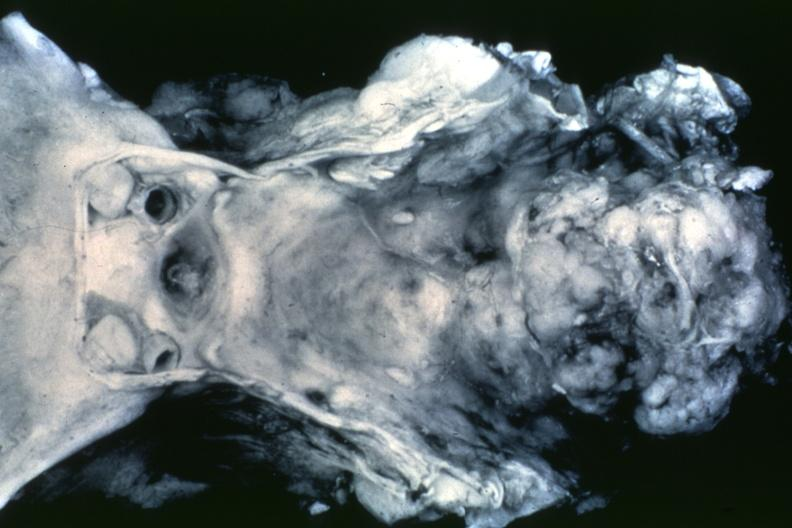what does this image show?
Answer the question using a single word or phrase. Black and white dr garcia tumors b68 